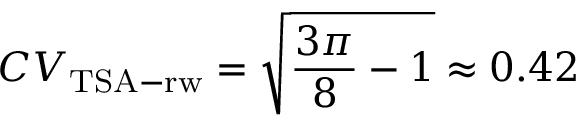<formula> <loc_0><loc_0><loc_500><loc_500>C V _ { T S A - r w } = \sqrt { \frac { 3 \pi } { 8 } - 1 } \approx 0 . 4 2</formula> 